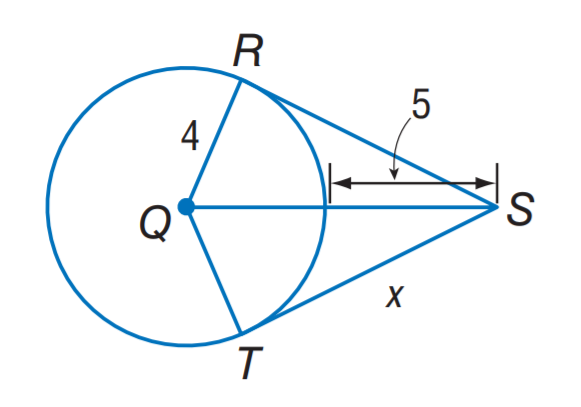Question: The segment is tangent to the circle. Find x to the nearest hundredth.
Choices:
A. 3.00
B. 4.03
C. 6.72
D. 8.06
Answer with the letter. Answer: D 